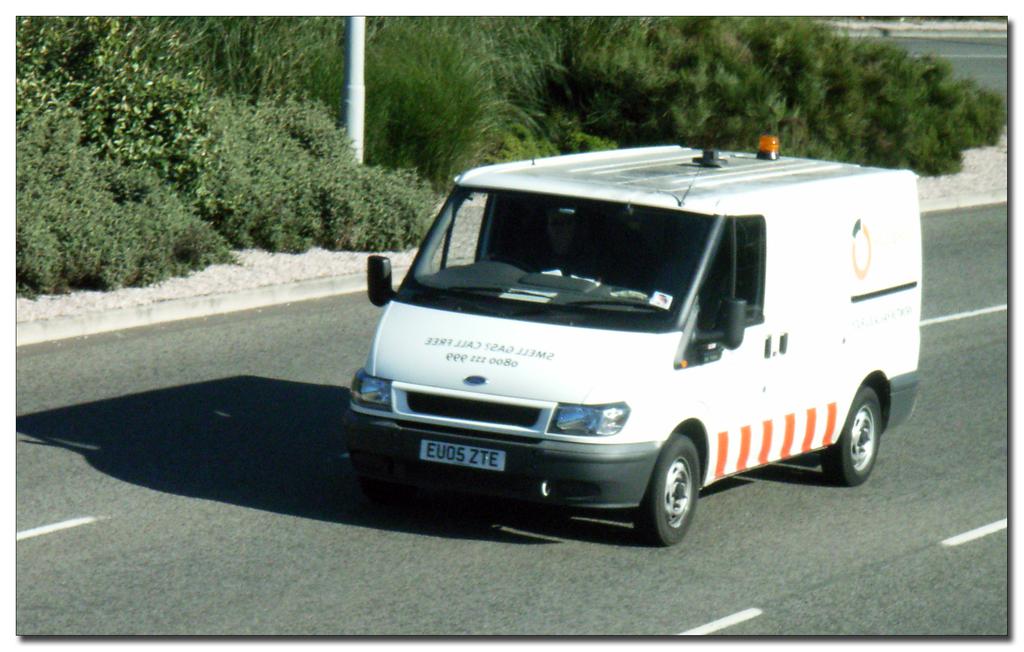What is the license plate of the white truck?
Make the answer very short. Eu05 zte. What do you do if you smell gas?
Offer a terse response. Unanswerable. 